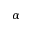<formula> <loc_0><loc_0><loc_500><loc_500>\alpha</formula> 